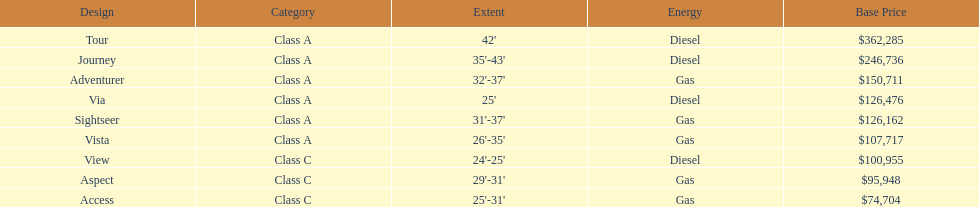What is the total number of class a models? 6. 